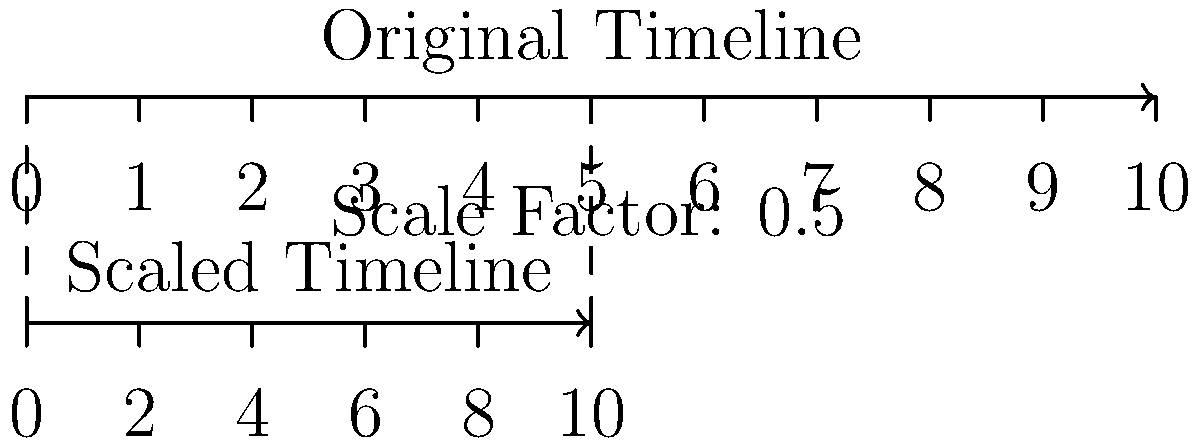A patient's timeline of significant life events spans 20 years. To analyze the impact of childhood trauma on current behaviors, you decide to create a scaled version of this timeline. If the original timeline is represented by a 10-unit line segment and the scaled version is half the length, what would be the corresponding unit on the scaled timeline for an event that occurred at year 14 in the original timeline? Let's approach this step-by-step:

1) First, we need to understand the scaling:
   - Original timeline: 20 years represented by 10 units
   - Scaled timeline: Half the length, so 5 units

2) Calculate the scale factor:
   $\text{Scale factor} = \frac{\text{New length}}{\text{Original length}} = \frac{5}{10} = 0.5$

3) Determine the relationship between years and units on the original timeline:
   - 20 years = 10 units
   - 1 year = 0.5 units

4) Convert 14 years to units on the original timeline:
   $14 \text{ years} \times 0.5 \text{ units/year} = 7 \text{ units}$

5) Apply the scale factor to find the position on the scaled timeline:
   $7 \text{ units} \times 0.5 \text{ (scale factor)} = 3.5 \text{ units}$

6) Convert the scaled units back to years:
   - On the scaled timeline, 5 units represent 20 years
   - 1 unit represents 4 years
   - 3.5 units represent: $3.5 \times 4 = 14 \text{ years}$

Therefore, on the scaled timeline, the event at year 14 would be represented at 3.5 units, which still corresponds to 14 years in the patient's life.
Answer: 3.5 units 